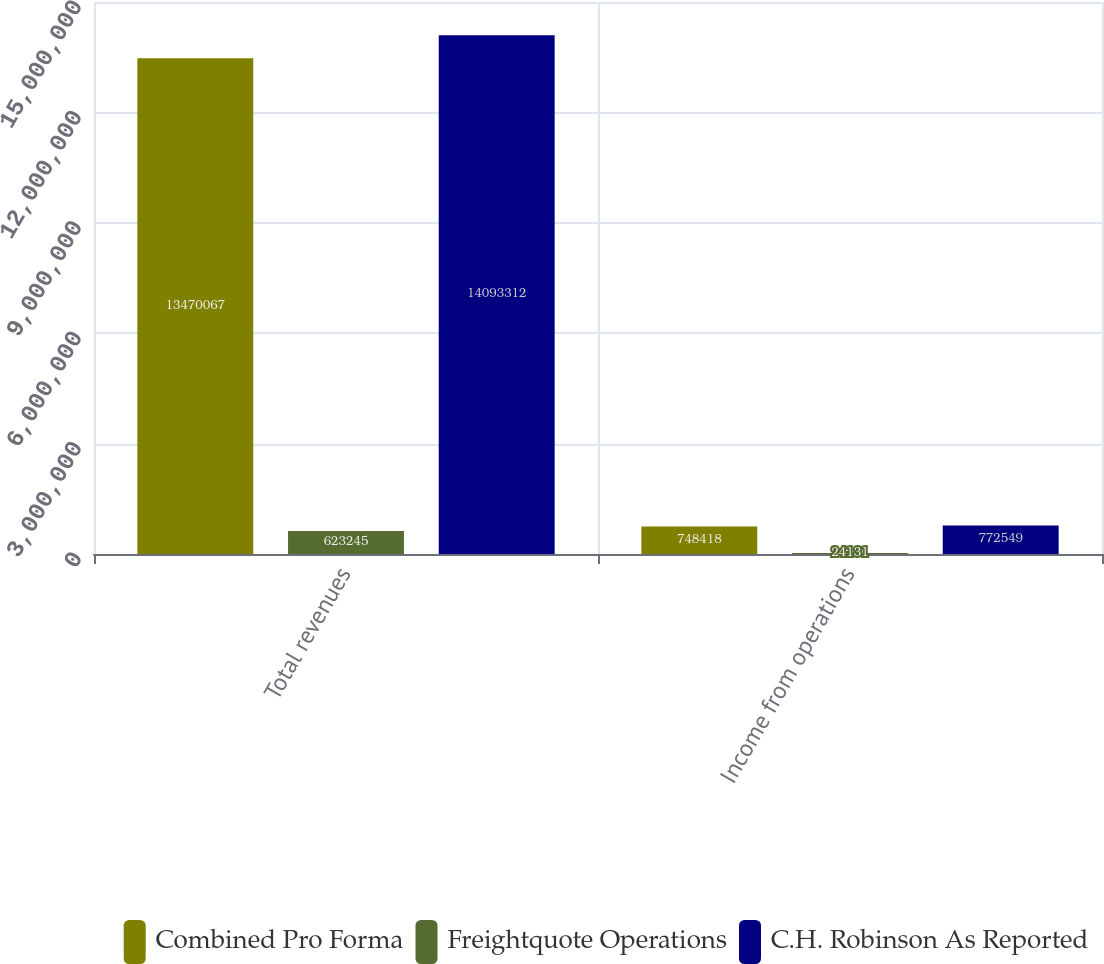Convert chart. <chart><loc_0><loc_0><loc_500><loc_500><stacked_bar_chart><ecel><fcel>Total revenues<fcel>Income from operations<nl><fcel>Combined Pro Forma<fcel>1.34701e+07<fcel>748418<nl><fcel>Freightquote Operations<fcel>623245<fcel>24131<nl><fcel>C.H. Robinson As Reported<fcel>1.40933e+07<fcel>772549<nl></chart> 